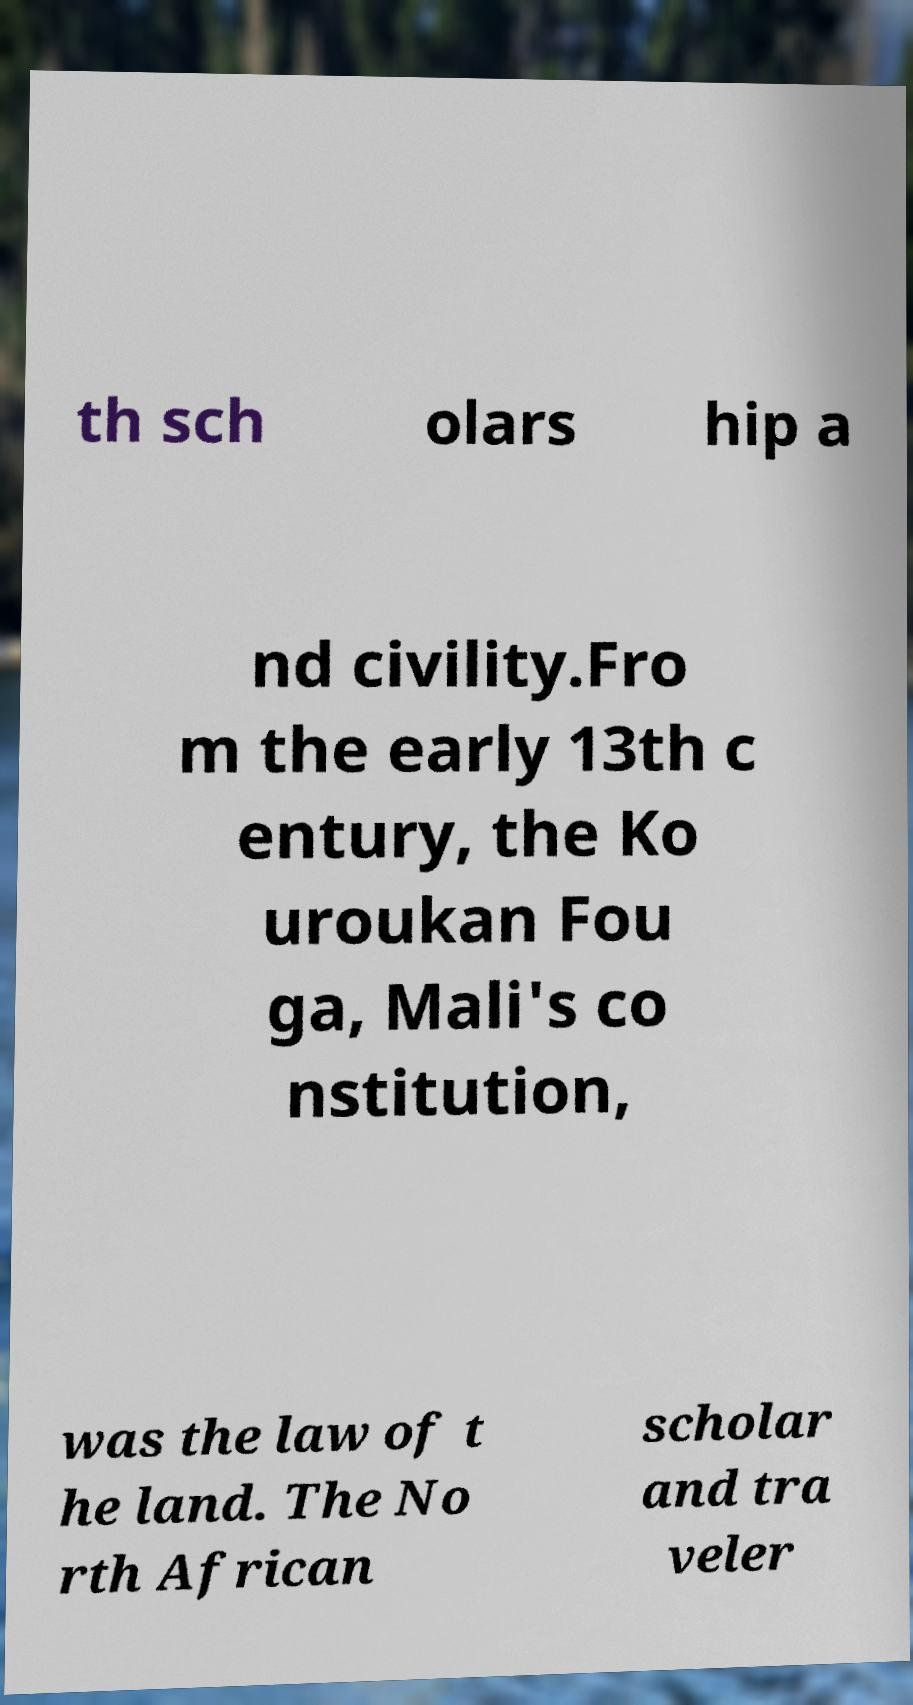Could you extract and type out the text from this image? th sch olars hip a nd civility.Fro m the early 13th c entury, the Ko uroukan Fou ga, Mali's co nstitution, was the law of t he land. The No rth African scholar and tra veler 